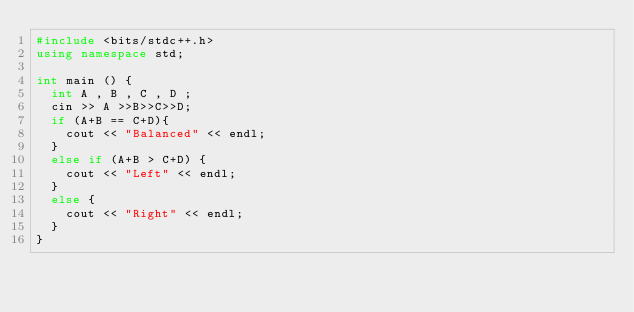<code> <loc_0><loc_0><loc_500><loc_500><_C++_>#include <bits/stdc++.h>
using namespace std;

int main () {
  int A , B , C , D ;
  cin >> A >>B>>C>>D;
  if (A+B == C+D){
    cout << "Balanced" << endl;
  }
  else if (A+B > C+D) {
    cout << "Left" << endl;
  }
  else {
    cout << "Right" << endl;
  }
}</code> 